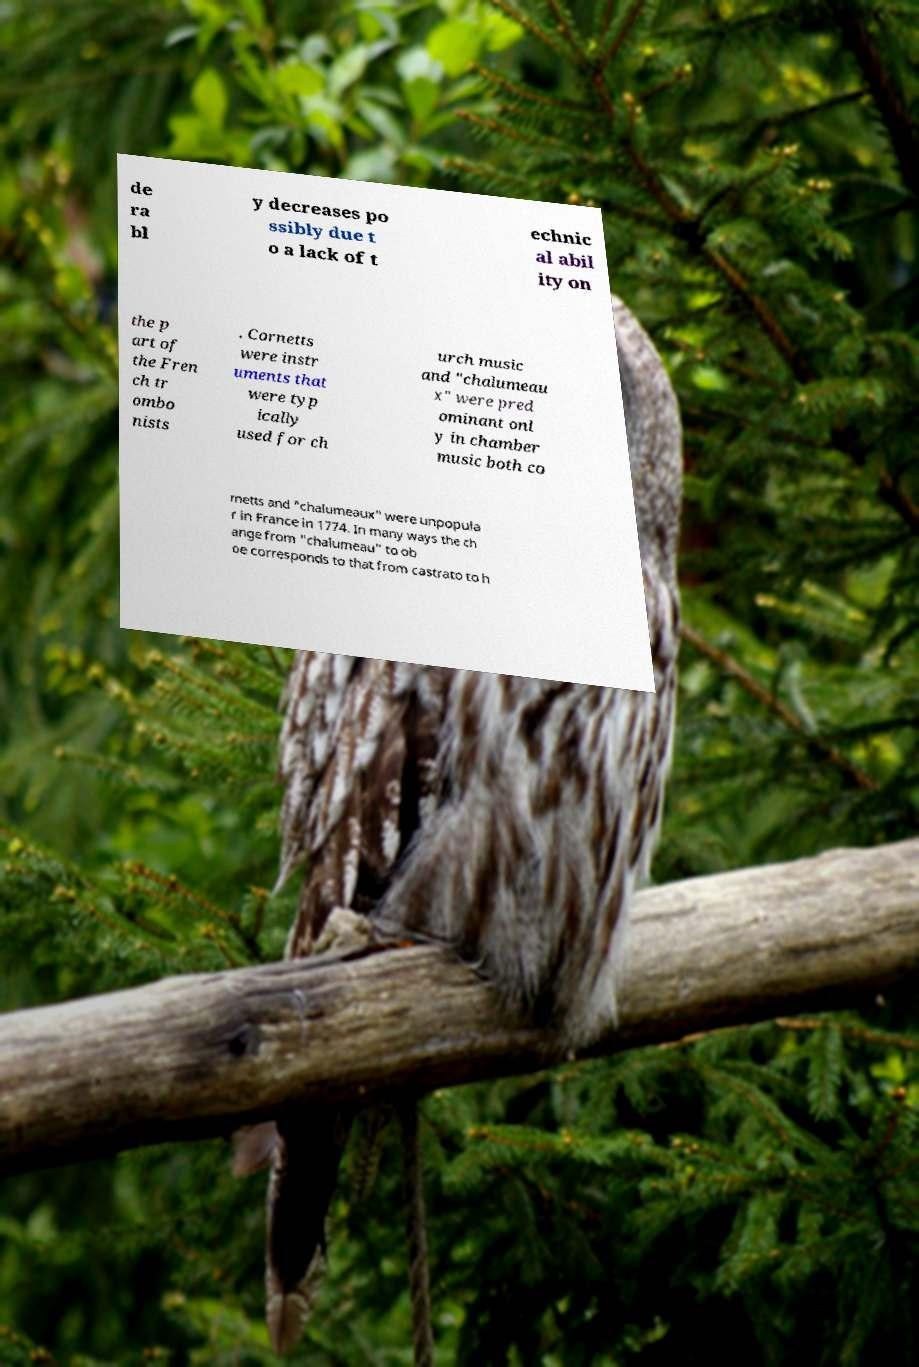Can you accurately transcribe the text from the provided image for me? de ra bl y decreases po ssibly due t o a lack of t echnic al abil ity on the p art of the Fren ch tr ombo nists . Cornetts were instr uments that were typ ically used for ch urch music and "chalumeau x" were pred ominant onl y in chamber music both co rnetts and "chalumeaux" were unpopula r in France in 1774. In many ways the ch ange from "chalumeau" to ob oe corresponds to that from castrato to h 